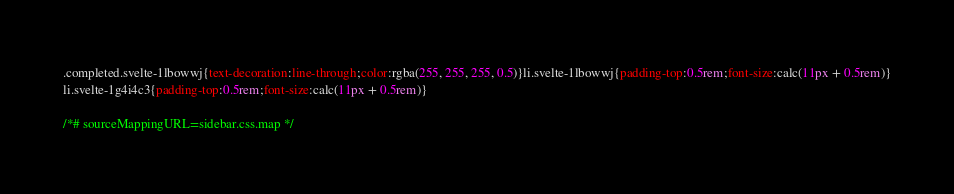<code> <loc_0><loc_0><loc_500><loc_500><_CSS_>.completed.svelte-1lbowwj{text-decoration:line-through;color:rgba(255, 255, 255, 0.5)}li.svelte-1lbowwj{padding-top:0.5rem;font-size:calc(11px + 0.5rem)}
li.svelte-1g4i4c3{padding-top:0.5rem;font-size:calc(11px + 0.5rem)}

/*# sourceMappingURL=sidebar.css.map */</code> 